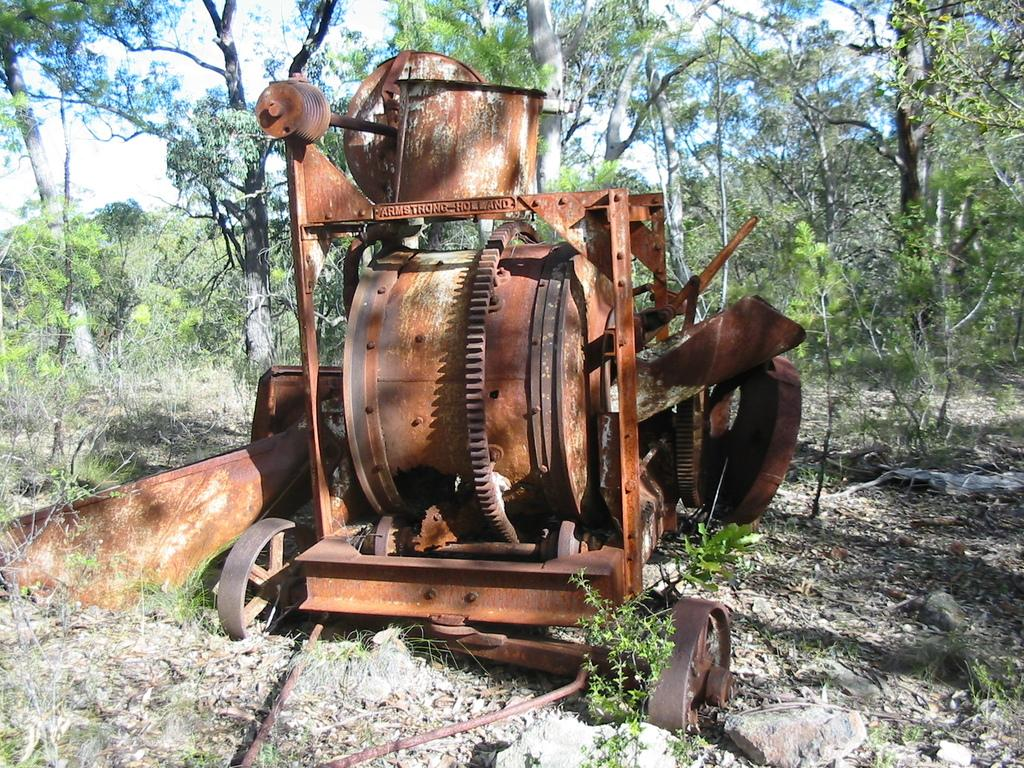What can be seen in the background of the image? There is sky and trees visible in the background of the image. What is present on the ground in the image? There are plants and stones on the ground in the image. What type of vehicle is in the image? There is an iron vehicle with wheels in the image. How many beds are visible in the image? There are no beds present in the image. What type of beetle can be seen crawling on the iron vehicle? There is no beetle present in the image. 